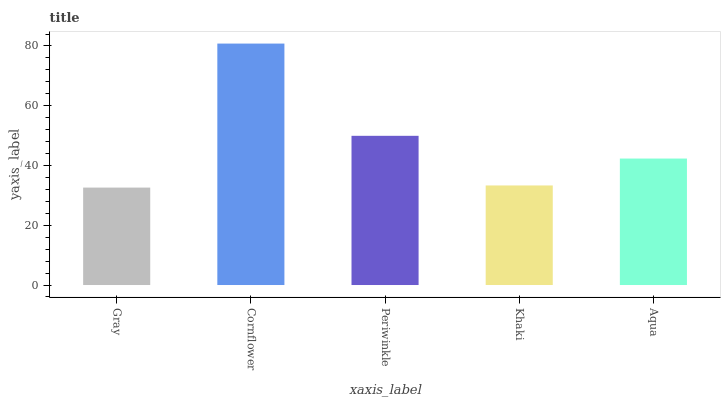Is Gray the minimum?
Answer yes or no. Yes. Is Cornflower the maximum?
Answer yes or no. Yes. Is Periwinkle the minimum?
Answer yes or no. No. Is Periwinkle the maximum?
Answer yes or no. No. Is Cornflower greater than Periwinkle?
Answer yes or no. Yes. Is Periwinkle less than Cornflower?
Answer yes or no. Yes. Is Periwinkle greater than Cornflower?
Answer yes or no. No. Is Cornflower less than Periwinkle?
Answer yes or no. No. Is Aqua the high median?
Answer yes or no. Yes. Is Aqua the low median?
Answer yes or no. Yes. Is Cornflower the high median?
Answer yes or no. No. Is Cornflower the low median?
Answer yes or no. No. 